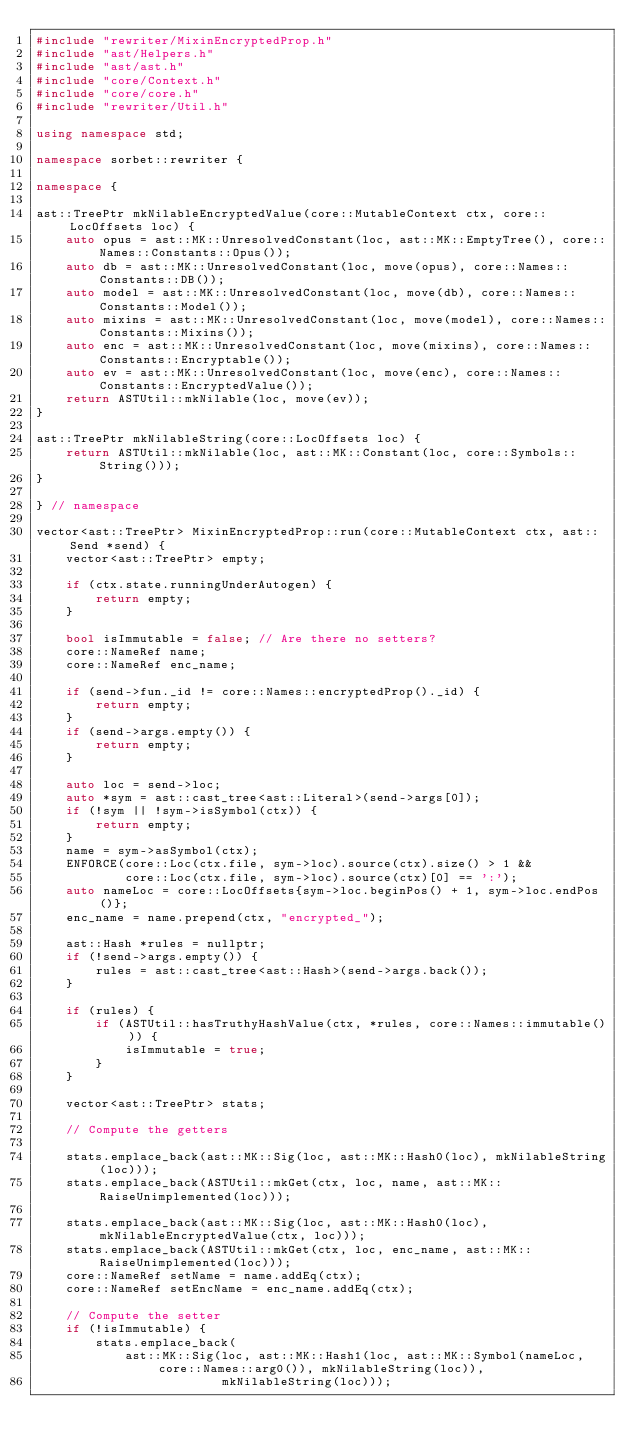<code> <loc_0><loc_0><loc_500><loc_500><_C++_>#include "rewriter/MixinEncryptedProp.h"
#include "ast/Helpers.h"
#include "ast/ast.h"
#include "core/Context.h"
#include "core/core.h"
#include "rewriter/Util.h"

using namespace std;

namespace sorbet::rewriter {

namespace {

ast::TreePtr mkNilableEncryptedValue(core::MutableContext ctx, core::LocOffsets loc) {
    auto opus = ast::MK::UnresolvedConstant(loc, ast::MK::EmptyTree(), core::Names::Constants::Opus());
    auto db = ast::MK::UnresolvedConstant(loc, move(opus), core::Names::Constants::DB());
    auto model = ast::MK::UnresolvedConstant(loc, move(db), core::Names::Constants::Model());
    auto mixins = ast::MK::UnresolvedConstant(loc, move(model), core::Names::Constants::Mixins());
    auto enc = ast::MK::UnresolvedConstant(loc, move(mixins), core::Names::Constants::Encryptable());
    auto ev = ast::MK::UnresolvedConstant(loc, move(enc), core::Names::Constants::EncryptedValue());
    return ASTUtil::mkNilable(loc, move(ev));
}

ast::TreePtr mkNilableString(core::LocOffsets loc) {
    return ASTUtil::mkNilable(loc, ast::MK::Constant(loc, core::Symbols::String()));
}

} // namespace

vector<ast::TreePtr> MixinEncryptedProp::run(core::MutableContext ctx, ast::Send *send) {
    vector<ast::TreePtr> empty;

    if (ctx.state.runningUnderAutogen) {
        return empty;
    }

    bool isImmutable = false; // Are there no setters?
    core::NameRef name;
    core::NameRef enc_name;

    if (send->fun._id != core::Names::encryptedProp()._id) {
        return empty;
    }
    if (send->args.empty()) {
        return empty;
    }

    auto loc = send->loc;
    auto *sym = ast::cast_tree<ast::Literal>(send->args[0]);
    if (!sym || !sym->isSymbol(ctx)) {
        return empty;
    }
    name = sym->asSymbol(ctx);
    ENFORCE(core::Loc(ctx.file, sym->loc).source(ctx).size() > 1 &&
            core::Loc(ctx.file, sym->loc).source(ctx)[0] == ':');
    auto nameLoc = core::LocOffsets{sym->loc.beginPos() + 1, sym->loc.endPos()};
    enc_name = name.prepend(ctx, "encrypted_");

    ast::Hash *rules = nullptr;
    if (!send->args.empty()) {
        rules = ast::cast_tree<ast::Hash>(send->args.back());
    }

    if (rules) {
        if (ASTUtil::hasTruthyHashValue(ctx, *rules, core::Names::immutable())) {
            isImmutable = true;
        }
    }

    vector<ast::TreePtr> stats;

    // Compute the getters

    stats.emplace_back(ast::MK::Sig(loc, ast::MK::Hash0(loc), mkNilableString(loc)));
    stats.emplace_back(ASTUtil::mkGet(ctx, loc, name, ast::MK::RaiseUnimplemented(loc)));

    stats.emplace_back(ast::MK::Sig(loc, ast::MK::Hash0(loc), mkNilableEncryptedValue(ctx, loc)));
    stats.emplace_back(ASTUtil::mkGet(ctx, loc, enc_name, ast::MK::RaiseUnimplemented(loc)));
    core::NameRef setName = name.addEq(ctx);
    core::NameRef setEncName = enc_name.addEq(ctx);

    // Compute the setter
    if (!isImmutable) {
        stats.emplace_back(
            ast::MK::Sig(loc, ast::MK::Hash1(loc, ast::MK::Symbol(nameLoc, core::Names::arg0()), mkNilableString(loc)),
                         mkNilableString(loc)));</code> 